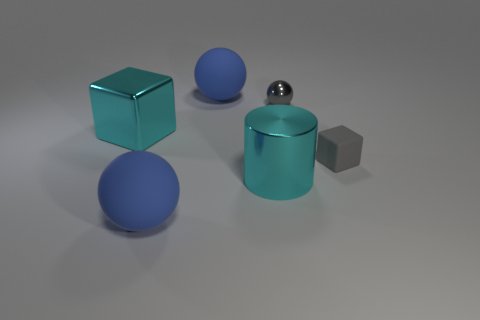Subtract all gray cylinders. How many blue spheres are left? 2 Subtract all rubber balls. How many balls are left? 1 Add 1 gray spheres. How many objects exist? 7 Subtract all cylinders. How many objects are left? 5 Subtract 1 spheres. How many spheres are left? 2 Subtract all green blocks. Subtract all purple cylinders. How many blocks are left? 2 Subtract all tiny purple matte balls. Subtract all blue rubber things. How many objects are left? 4 Add 1 cyan cylinders. How many cyan cylinders are left? 2 Add 5 cyan shiny blocks. How many cyan shiny blocks exist? 6 Subtract all gray blocks. How many blocks are left? 1 